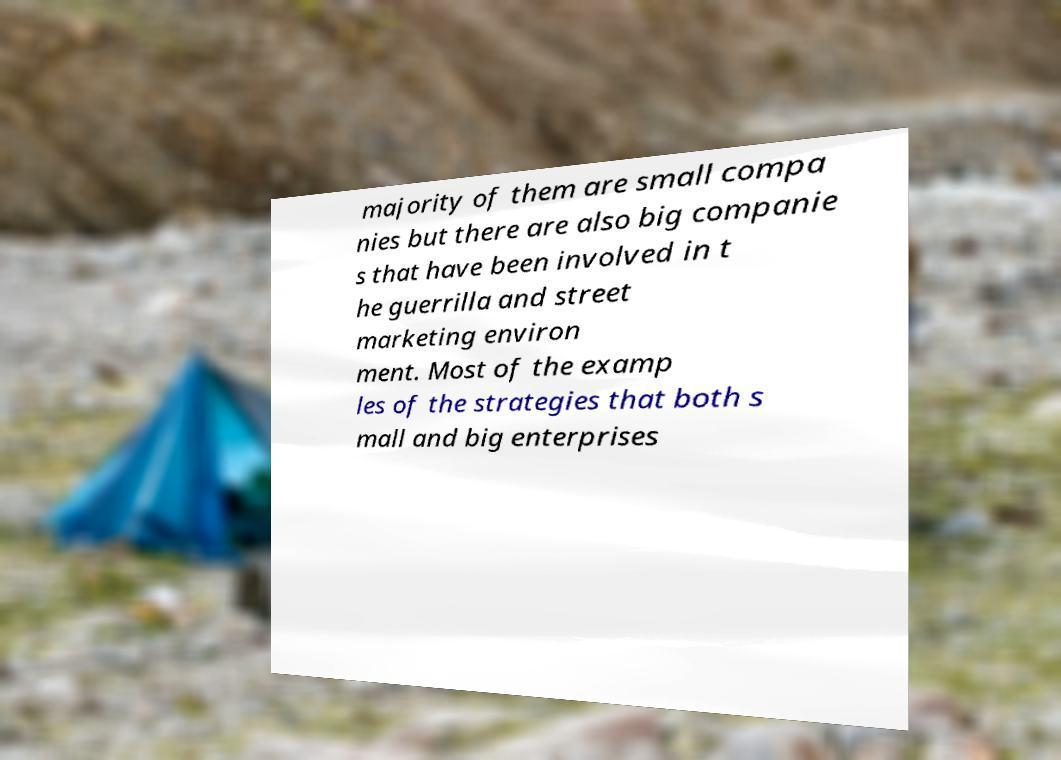For documentation purposes, I need the text within this image transcribed. Could you provide that? majority of them are small compa nies but there are also big companie s that have been involved in t he guerrilla and street marketing environ ment. Most of the examp les of the strategies that both s mall and big enterprises 